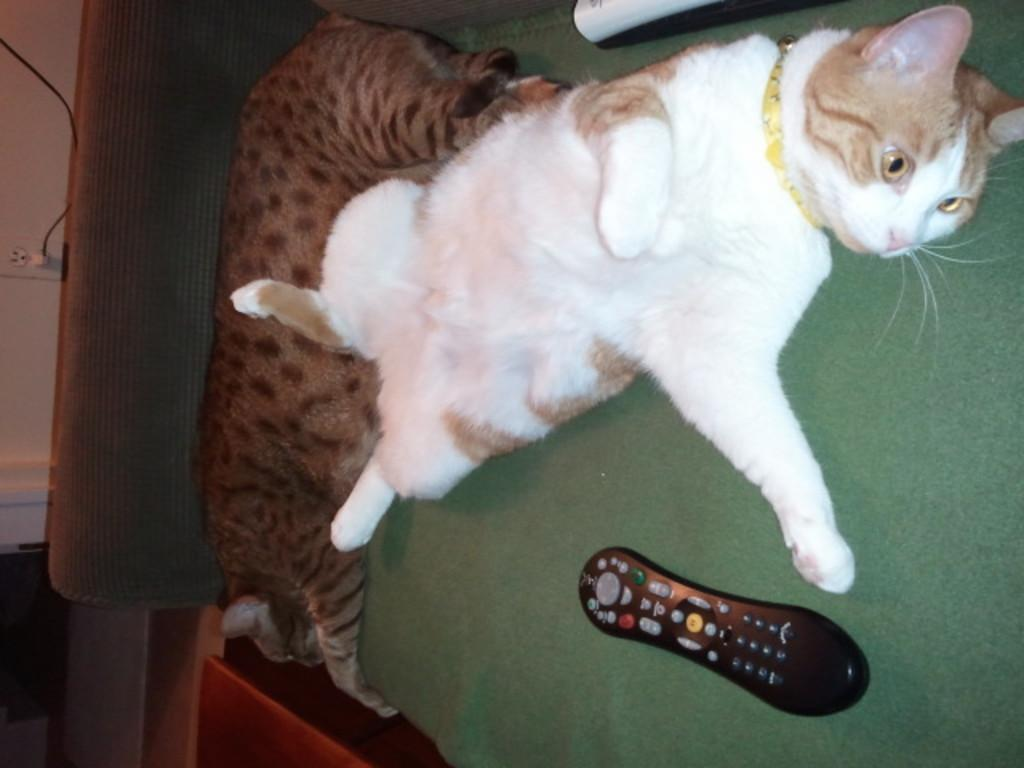What type of animals are in the picture? There are cats in the picture. What object can be seen near the cats? There is a remote in the picture. What piece of furniture is visible in the picture? It appears to be a bed in the picture. Where is the table located in the picture? There is a table on the left side of the picture. What type of hill can be seen in the background of the picture? There is no hill visible in the picture; it features cats, a remote, a bed, and a table. 